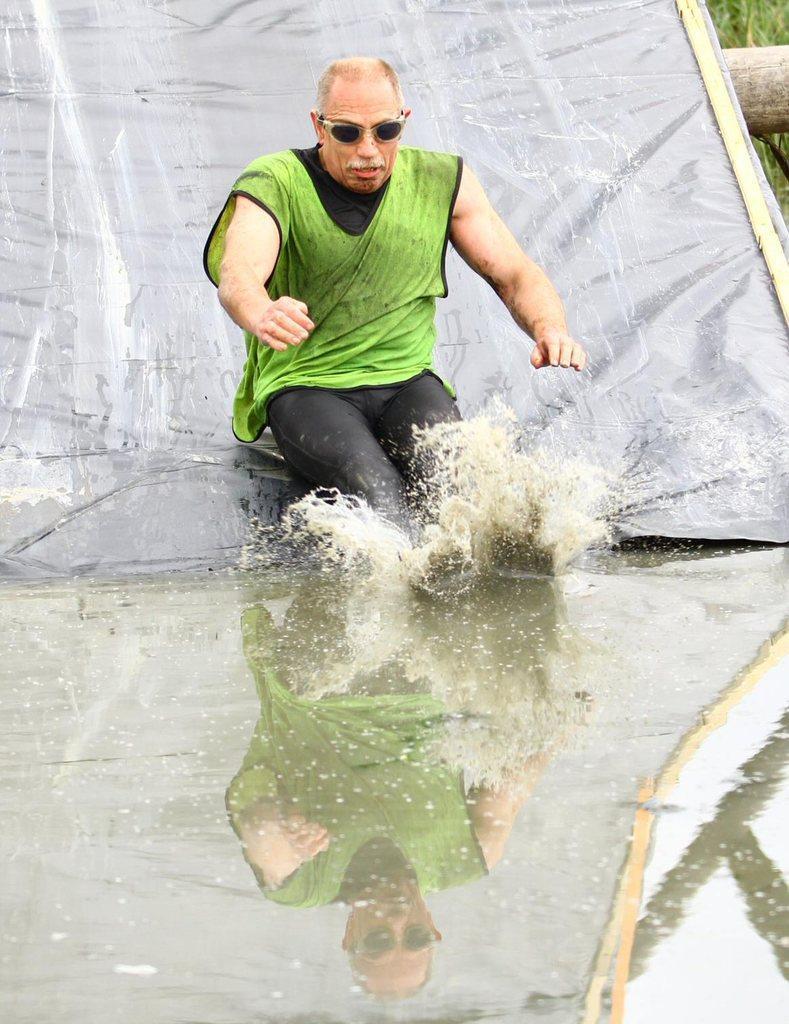How would you summarize this image in a sentence or two? At the bottom of the image there is a water and there is a person sitting on a water slide and we can see the reflection of the person in the water. At the top right side there is a wooden stick and grass. 